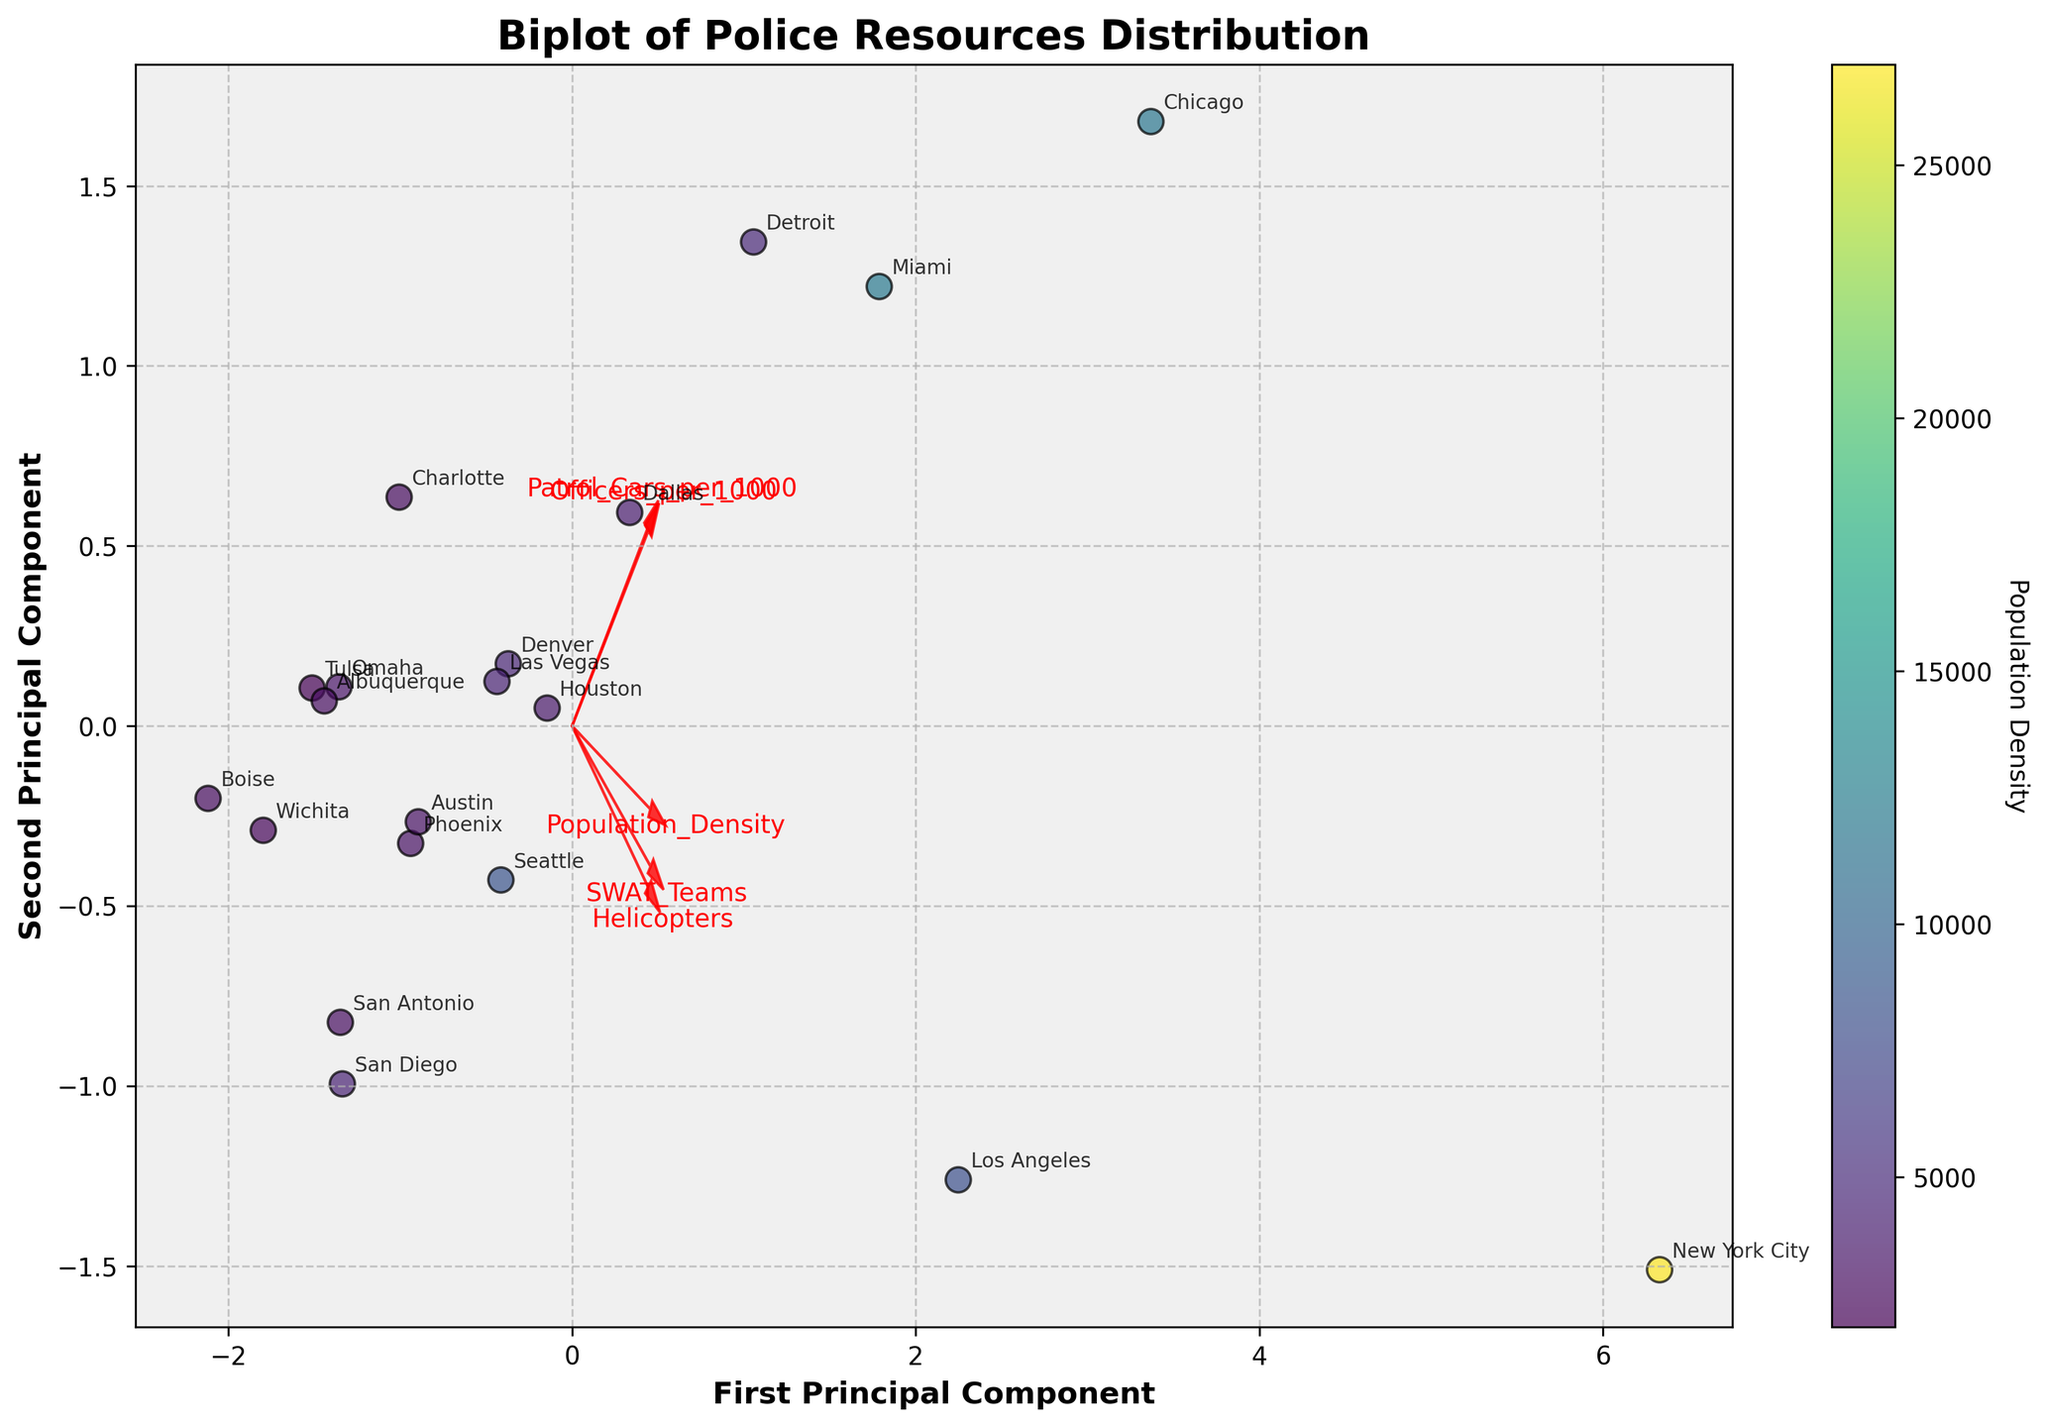What is the title of the plot? The title is written at the top of the plot, which helps in understanding the overall subject of the plot.
Answer: Biplot of Police Resources Distribution How many principal components are displayed in the plot? The plot's labels on the axes indicate the principal components being displayed.
Answer: 2 Which feature has the highest influence on the first principal component? The length and direction of the arrows give an indication of the influence each feature has on the principal components. The feature with the longest arrow in the direction of the first principal component has the highest influence.
Answer: Population_Density Which city appears to be most closely associated with high population density? By looking at the color gradient and the position of the city points relative to the population density vector, we can determine which city aligns more with high population density.
Answer: New York City Which feature vector is least influenced by both the principal components? Shorter arrows indicate less influence on the principal components. The feature with the shortest total vector length is the least influenced.
Answer: Patrol_Cars_per_1000 What is the relationship between 'Officers_per_1000' and the first principal component based on the figure? Observing the direction and magnitude of the arrow associated with 'Officers_per_1000' in the biplot will show its relationship to the first principal component. The direction and length of the arrow towards the first principal component axis indicate a positive or negative relationship.
Answer: Positive relationship How many arrows are there in the plot representing different features? Counting the number of arrows in the plot representing different features visually provides this information. Each arrow corresponds to a different feature listed.
Answer: 5 Which city has a higher position on the second principal component, Chicago or Los Angeles? Comparing the vertical positions (second principal component) of Chicago and Los Angeles on the plot helps to answer this. The city positioned higher on the vertical axis has a higher value on the second principal component.
Answer: Chicago Explain how population density influences the arrangement of cities on the Biplot? The color gradient of the scatter points, which is based on the population density, reveals this influence. Cities with different population densities are arranged based on their values indicated by the color bar. Additionally, the direction and length of the 'Population_Density' vector provide insight into its influence on the principal components.
Answer: Higher population density places cities further in the direction of the 'Population_Density' vector on the plot Which feature aligns most closely with the first principal component positively but not the second principal component? Observing the arrows' alignment with axes, the feature with an arrow almost entirely in the direction of the first principal component and not the second will be most closely aligned positively with the first principal component.
Answer: Population_Density 